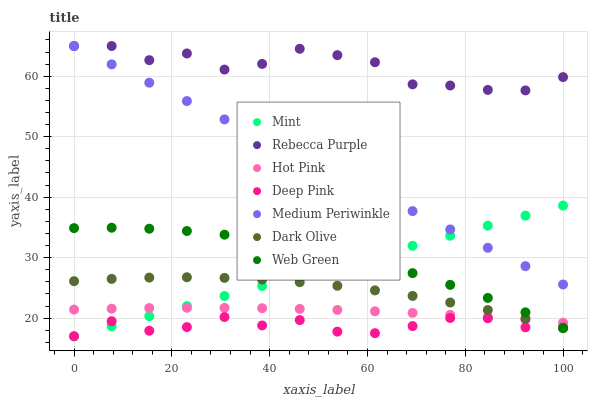Does Deep Pink have the minimum area under the curve?
Answer yes or no. Yes. Does Rebecca Purple have the maximum area under the curve?
Answer yes or no. Yes. Does Dark Olive have the minimum area under the curve?
Answer yes or no. No. Does Dark Olive have the maximum area under the curve?
Answer yes or no. No. Is Medium Periwinkle the smoothest?
Answer yes or no. Yes. Is Rebecca Purple the roughest?
Answer yes or no. Yes. Is Dark Olive the smoothest?
Answer yes or no. No. Is Dark Olive the roughest?
Answer yes or no. No. Does Deep Pink have the lowest value?
Answer yes or no. Yes. Does Dark Olive have the lowest value?
Answer yes or no. No. Does Rebecca Purple have the highest value?
Answer yes or no. Yes. Does Dark Olive have the highest value?
Answer yes or no. No. Is Mint less than Rebecca Purple?
Answer yes or no. Yes. Is Medium Periwinkle greater than Deep Pink?
Answer yes or no. Yes. Does Medium Periwinkle intersect Rebecca Purple?
Answer yes or no. Yes. Is Medium Periwinkle less than Rebecca Purple?
Answer yes or no. No. Is Medium Periwinkle greater than Rebecca Purple?
Answer yes or no. No. Does Mint intersect Rebecca Purple?
Answer yes or no. No. 